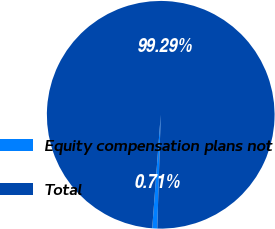Convert chart. <chart><loc_0><loc_0><loc_500><loc_500><pie_chart><fcel>Equity compensation plans not<fcel>Total<nl><fcel>0.71%<fcel>99.29%<nl></chart> 